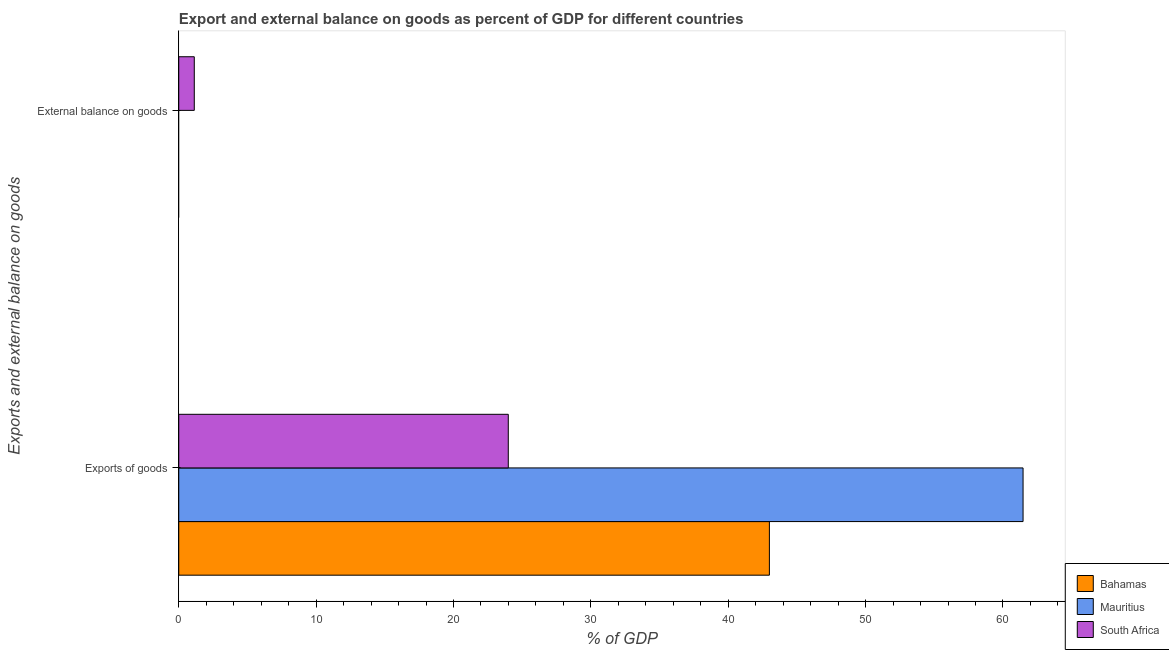How many different coloured bars are there?
Provide a succinct answer. 3. Are the number of bars per tick equal to the number of legend labels?
Provide a succinct answer. No. Are the number of bars on each tick of the Y-axis equal?
Your response must be concise. No. What is the label of the 1st group of bars from the top?
Keep it short and to the point. External balance on goods. What is the external balance on goods as percentage of gdp in South Africa?
Keep it short and to the point. 1.13. Across all countries, what is the maximum export of goods as percentage of gdp?
Your answer should be compact. 61.46. Across all countries, what is the minimum export of goods as percentage of gdp?
Offer a very short reply. 23.99. In which country was the export of goods as percentage of gdp maximum?
Make the answer very short. Mauritius. What is the total export of goods as percentage of gdp in the graph?
Give a very brief answer. 128.45. What is the difference between the export of goods as percentage of gdp in Bahamas and that in South Africa?
Offer a very short reply. 19.01. What is the difference between the export of goods as percentage of gdp in Mauritius and the external balance on goods as percentage of gdp in South Africa?
Make the answer very short. 60.33. What is the average export of goods as percentage of gdp per country?
Provide a short and direct response. 42.82. What is the difference between the external balance on goods as percentage of gdp and export of goods as percentage of gdp in South Africa?
Ensure brevity in your answer.  -22.86. What is the ratio of the export of goods as percentage of gdp in Mauritius to that in Bahamas?
Keep it short and to the point. 1.43. Is the export of goods as percentage of gdp in Bahamas less than that in South Africa?
Give a very brief answer. No. In how many countries, is the external balance on goods as percentage of gdp greater than the average external balance on goods as percentage of gdp taken over all countries?
Give a very brief answer. 1. Are all the bars in the graph horizontal?
Give a very brief answer. Yes. How many countries are there in the graph?
Give a very brief answer. 3. Does the graph contain any zero values?
Your response must be concise. Yes. How many legend labels are there?
Give a very brief answer. 3. How are the legend labels stacked?
Keep it short and to the point. Vertical. What is the title of the graph?
Give a very brief answer. Export and external balance on goods as percent of GDP for different countries. Does "Ecuador" appear as one of the legend labels in the graph?
Provide a short and direct response. No. What is the label or title of the X-axis?
Keep it short and to the point. % of GDP. What is the label or title of the Y-axis?
Provide a short and direct response. Exports and external balance on goods. What is the % of GDP of Bahamas in Exports of goods?
Offer a terse response. 43. What is the % of GDP of Mauritius in Exports of goods?
Keep it short and to the point. 61.46. What is the % of GDP in South Africa in Exports of goods?
Give a very brief answer. 23.99. What is the % of GDP of South Africa in External balance on goods?
Make the answer very short. 1.13. Across all Exports and external balance on goods, what is the maximum % of GDP of Bahamas?
Your answer should be very brief. 43. Across all Exports and external balance on goods, what is the maximum % of GDP of Mauritius?
Offer a very short reply. 61.46. Across all Exports and external balance on goods, what is the maximum % of GDP of South Africa?
Your answer should be compact. 23.99. Across all Exports and external balance on goods, what is the minimum % of GDP in Bahamas?
Offer a terse response. 0. Across all Exports and external balance on goods, what is the minimum % of GDP of Mauritius?
Offer a very short reply. 0. Across all Exports and external balance on goods, what is the minimum % of GDP of South Africa?
Provide a succinct answer. 1.13. What is the total % of GDP in Bahamas in the graph?
Make the answer very short. 43. What is the total % of GDP in Mauritius in the graph?
Keep it short and to the point. 61.46. What is the total % of GDP in South Africa in the graph?
Keep it short and to the point. 25.12. What is the difference between the % of GDP of South Africa in Exports of goods and that in External balance on goods?
Give a very brief answer. 22.86. What is the difference between the % of GDP in Bahamas in Exports of goods and the % of GDP in South Africa in External balance on goods?
Make the answer very short. 41.87. What is the difference between the % of GDP of Mauritius in Exports of goods and the % of GDP of South Africa in External balance on goods?
Ensure brevity in your answer.  60.33. What is the average % of GDP of Bahamas per Exports and external balance on goods?
Your answer should be very brief. 21.5. What is the average % of GDP in Mauritius per Exports and external balance on goods?
Your answer should be compact. 30.73. What is the average % of GDP of South Africa per Exports and external balance on goods?
Keep it short and to the point. 12.56. What is the difference between the % of GDP of Bahamas and % of GDP of Mauritius in Exports of goods?
Offer a very short reply. -18.47. What is the difference between the % of GDP in Bahamas and % of GDP in South Africa in Exports of goods?
Ensure brevity in your answer.  19.01. What is the difference between the % of GDP in Mauritius and % of GDP in South Africa in Exports of goods?
Provide a succinct answer. 37.47. What is the ratio of the % of GDP in South Africa in Exports of goods to that in External balance on goods?
Keep it short and to the point. 21.24. What is the difference between the highest and the second highest % of GDP in South Africa?
Your answer should be very brief. 22.86. What is the difference between the highest and the lowest % of GDP of Bahamas?
Keep it short and to the point. 43. What is the difference between the highest and the lowest % of GDP of Mauritius?
Make the answer very short. 61.46. What is the difference between the highest and the lowest % of GDP of South Africa?
Your response must be concise. 22.86. 